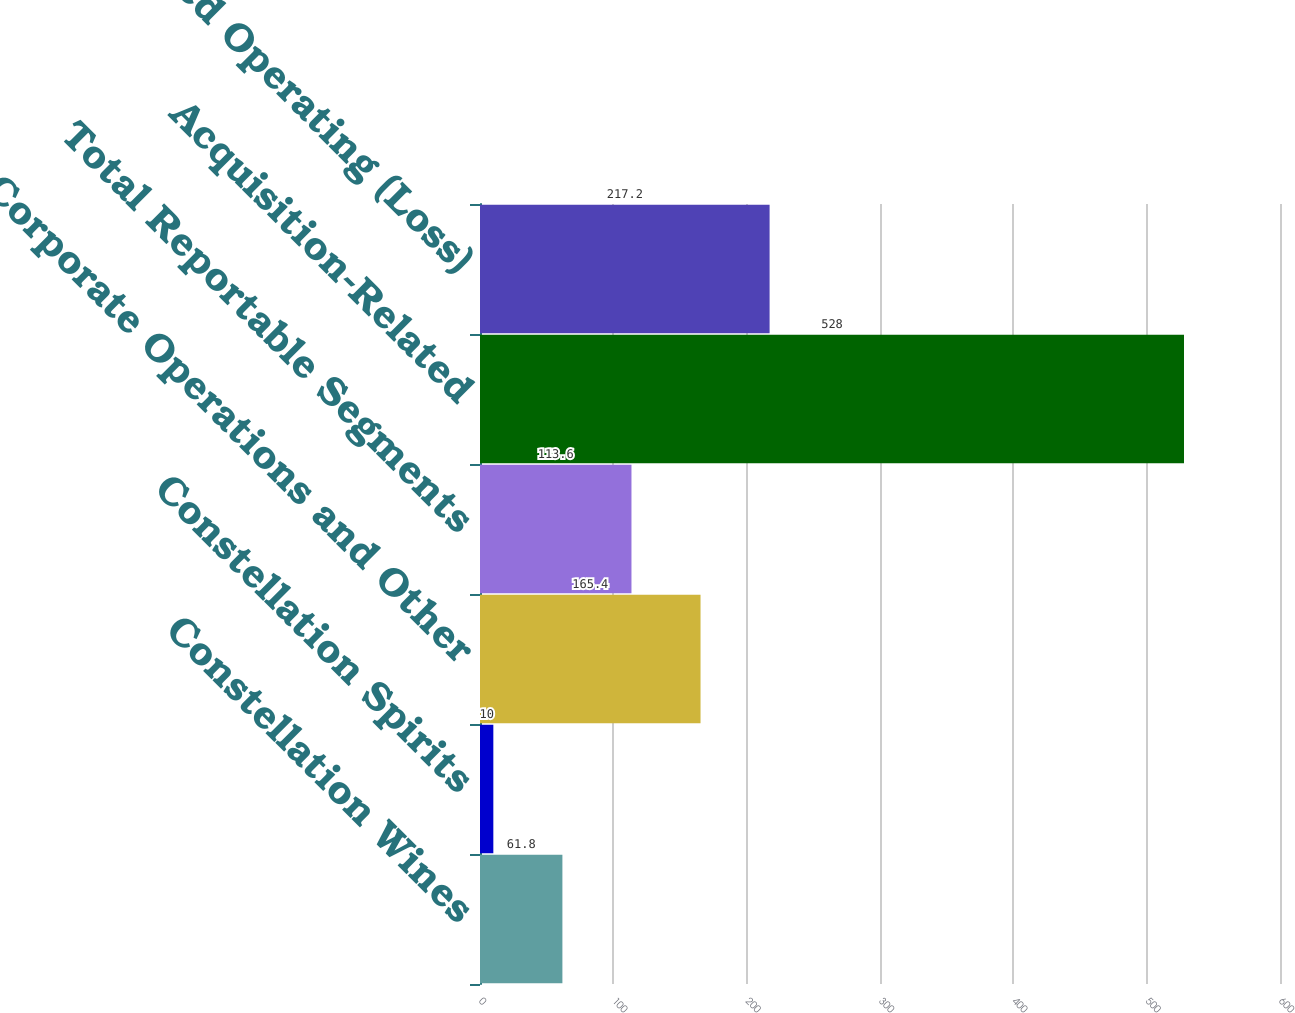<chart> <loc_0><loc_0><loc_500><loc_500><bar_chart><fcel>Constellation Wines<fcel>Constellation Spirits<fcel>Corporate Operations and Other<fcel>Total Reportable Segments<fcel>Acquisition-Related<fcel>Consolidated Operating (Loss)<nl><fcel>61.8<fcel>10<fcel>165.4<fcel>113.6<fcel>528<fcel>217.2<nl></chart> 